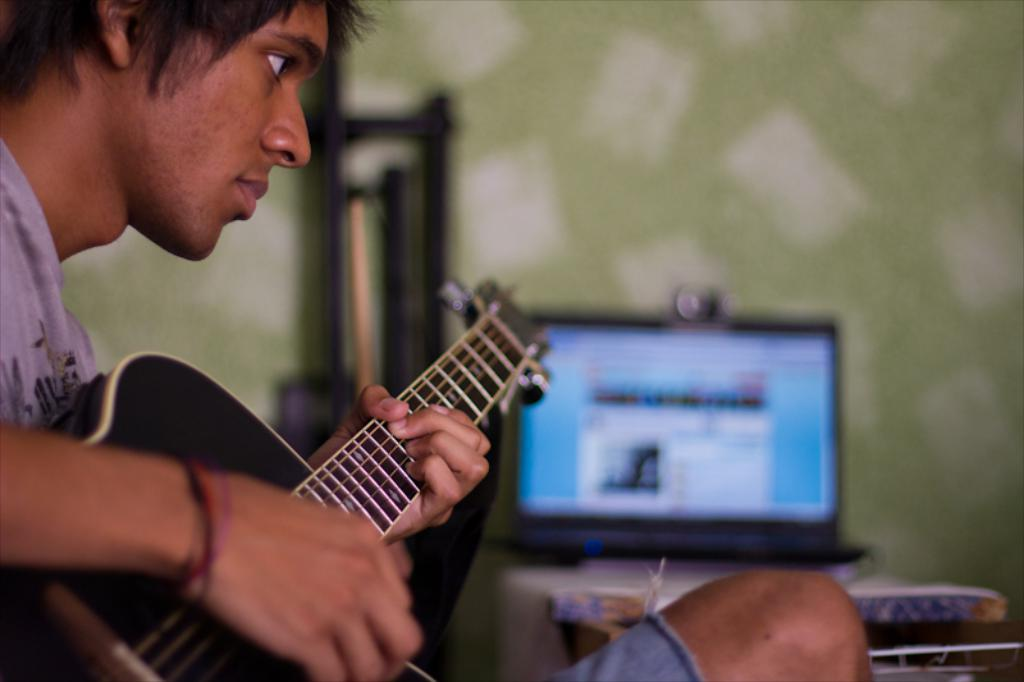What is the man in the image doing? The man is sitting and playing the guitar. What object is on the table in the image? There is a laptop on a table in the image. What is the background of the image? There is a wall in the image. What type of grain is being harvested in the image? There is no grain or harvesting activity present in the image. How many spiders are crawling on the wall in the image? There are no spiders visible in the image. 